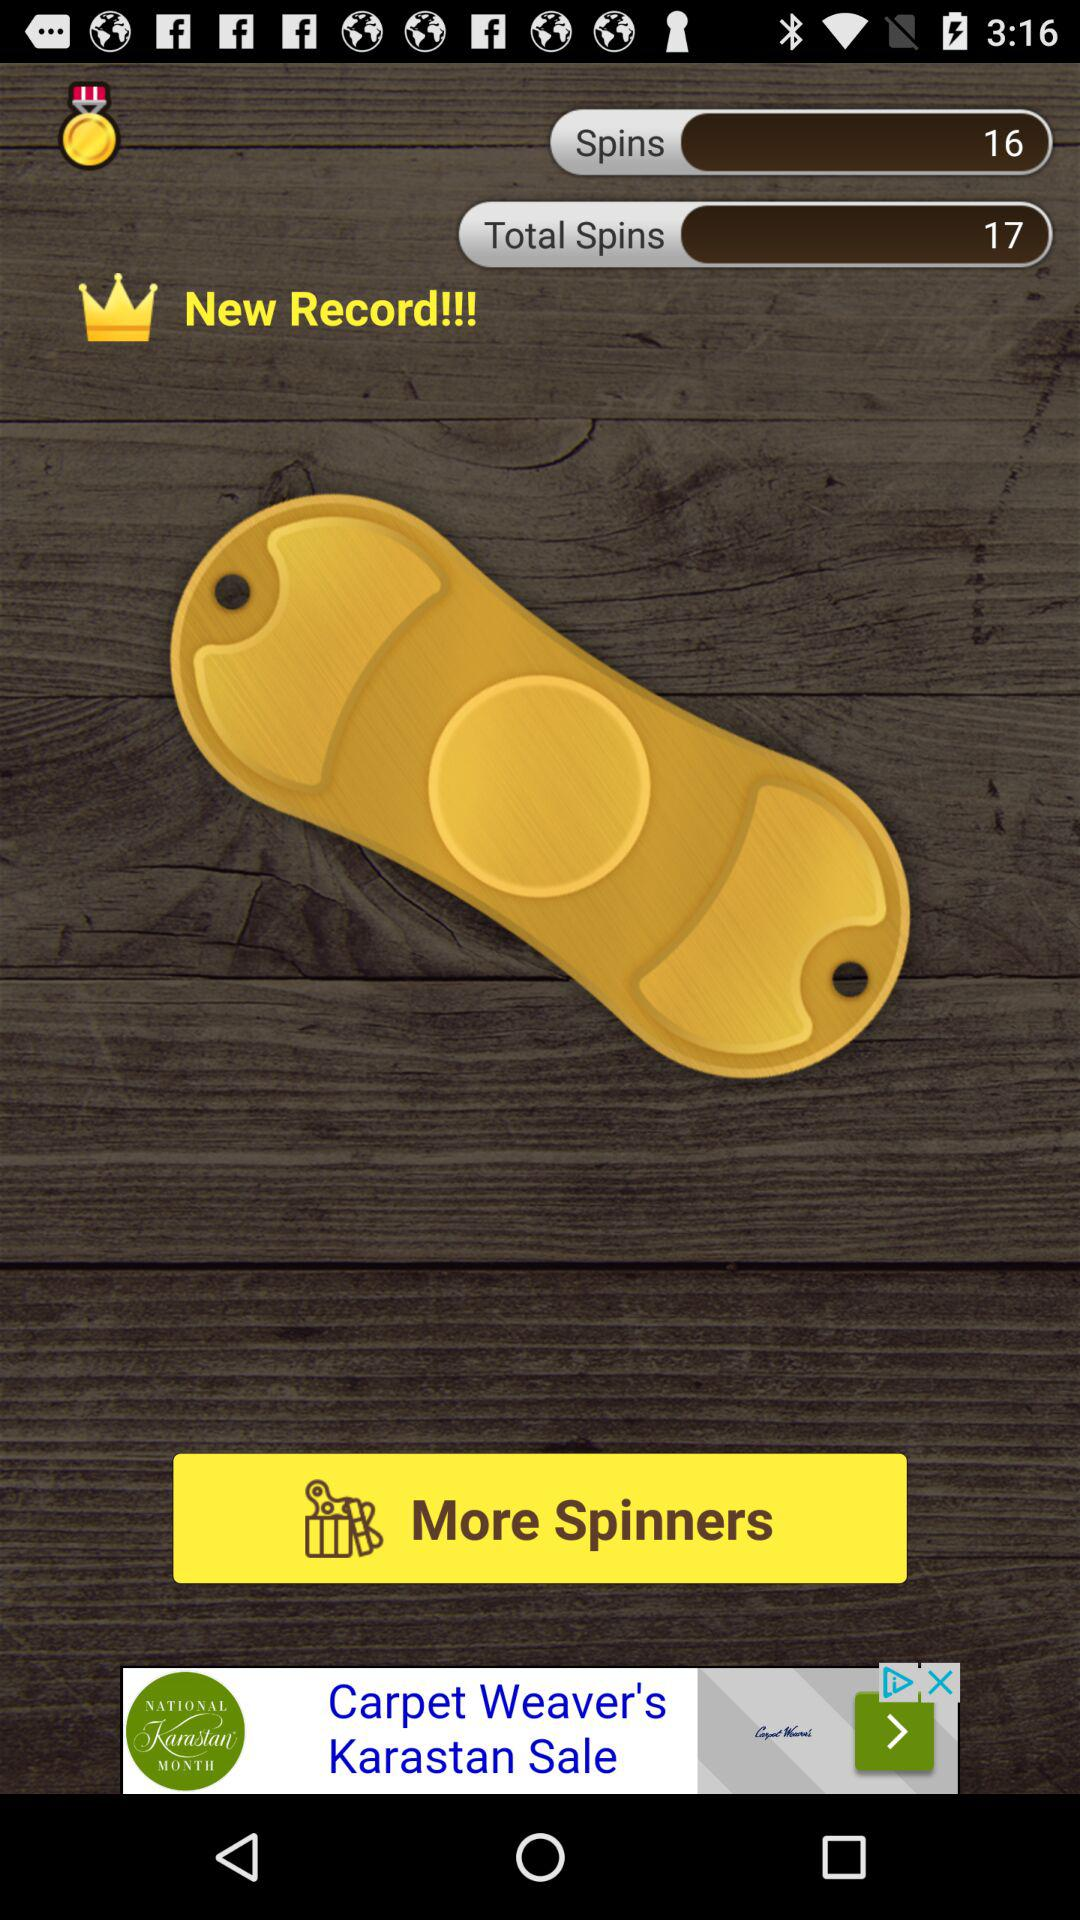What is the number of spins available? The number of spins is 16. 